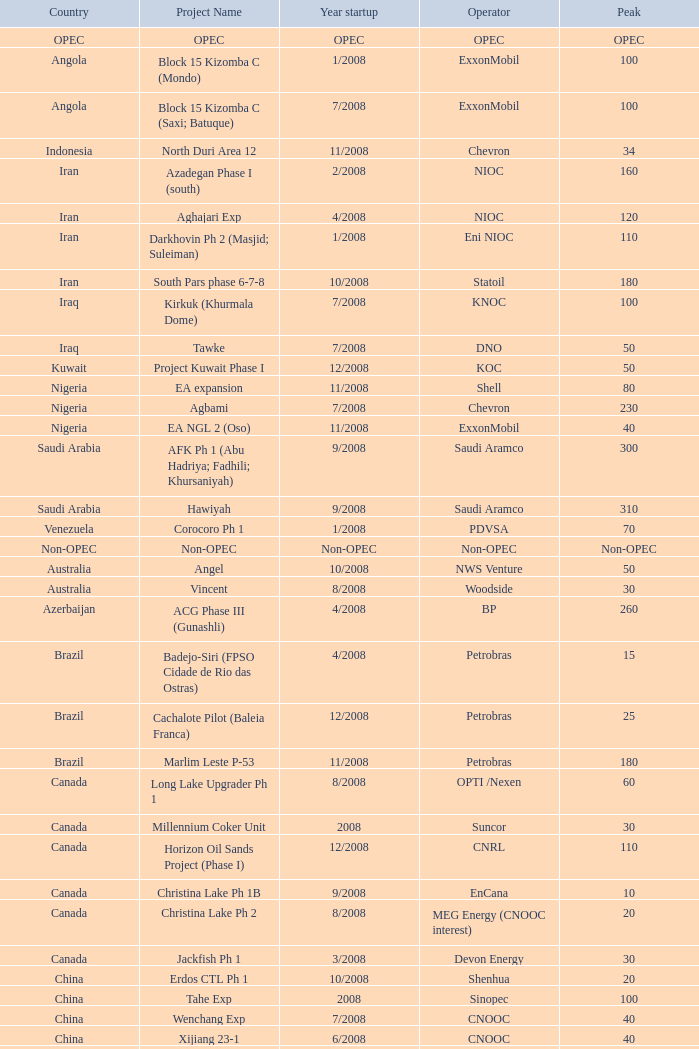What operator features a maximum point of 55? PEMEX. 